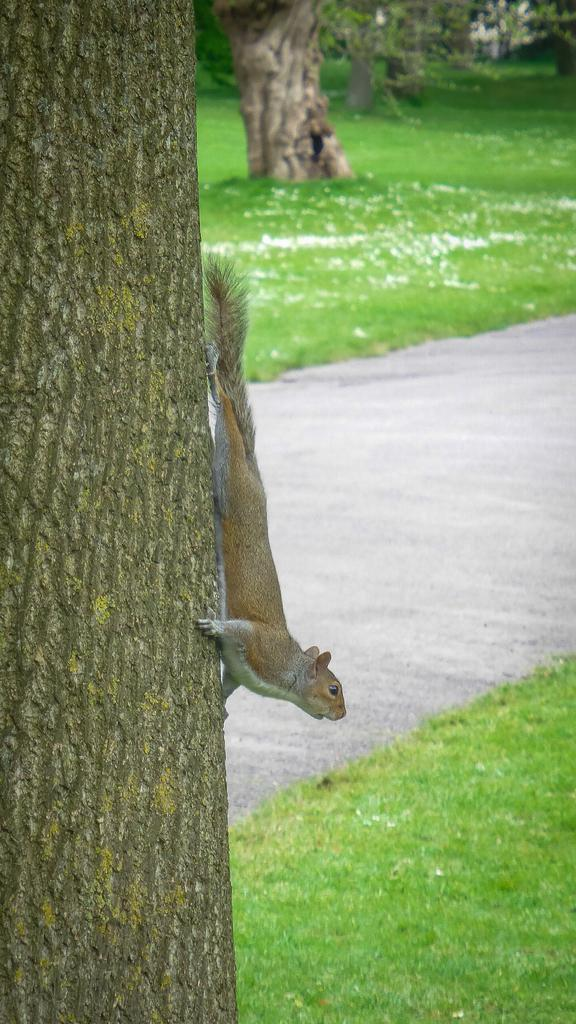What animal can be seen in the image? There is a squirrel on a tree trunk in the image. What is behind the tree in the image? There is a road behind the tree in the image. What type of vegetation is visible in the background of the image? There are trees in the background of the image. What type of ground cover is present in the background of the image? There is grass on the ground in the background. What type of ground cover is present at the bottom of the image? There is grass at the bottom of the image. What type of songs can be heard playing from the bottle in the image? There is no bottle or songs present in the image. Is there a stove visible in the image? No, there is no stove present in the image. 